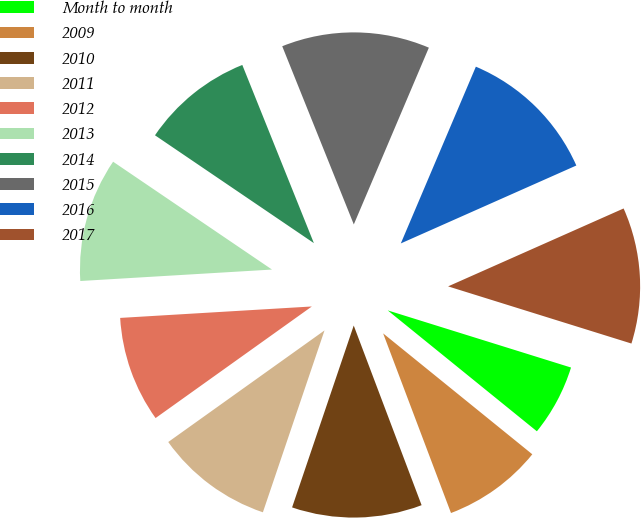Convert chart to OTSL. <chart><loc_0><loc_0><loc_500><loc_500><pie_chart><fcel>Month to month<fcel>2009<fcel>2010<fcel>2011<fcel>2012<fcel>2013<fcel>2014<fcel>2015<fcel>2016<fcel>2017<nl><fcel>6.03%<fcel>8.41%<fcel>10.95%<fcel>9.93%<fcel>8.92%<fcel>10.44%<fcel>9.43%<fcel>12.47%<fcel>11.96%<fcel>11.46%<nl></chart> 